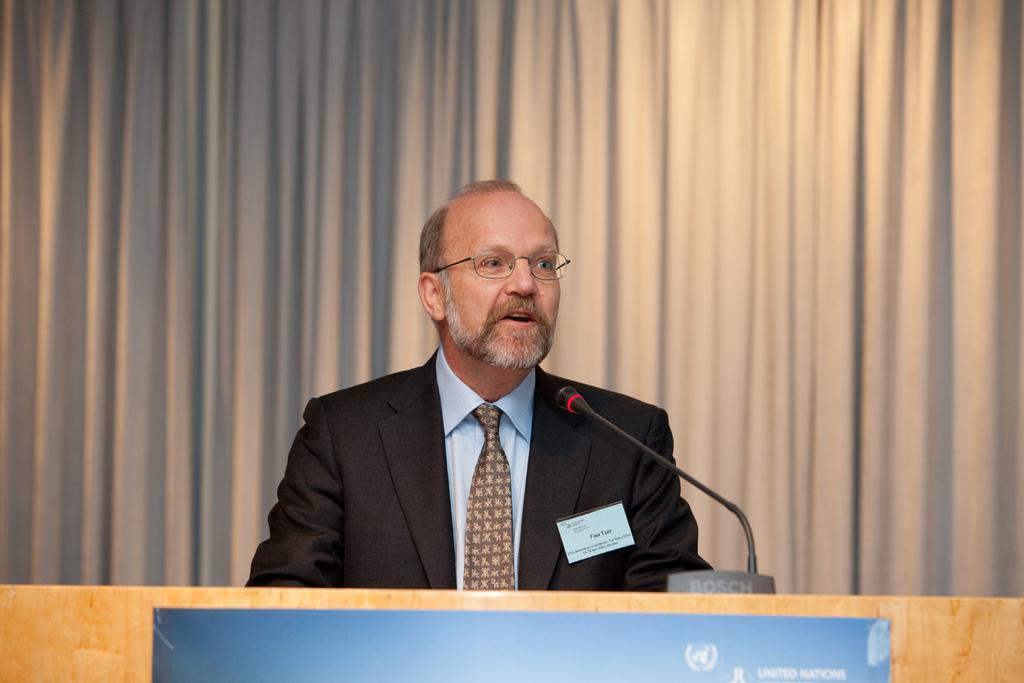Can you describe this image briefly? In this image there is a man sitting in front of table where we can see there is a microphone and curtain behind him. 